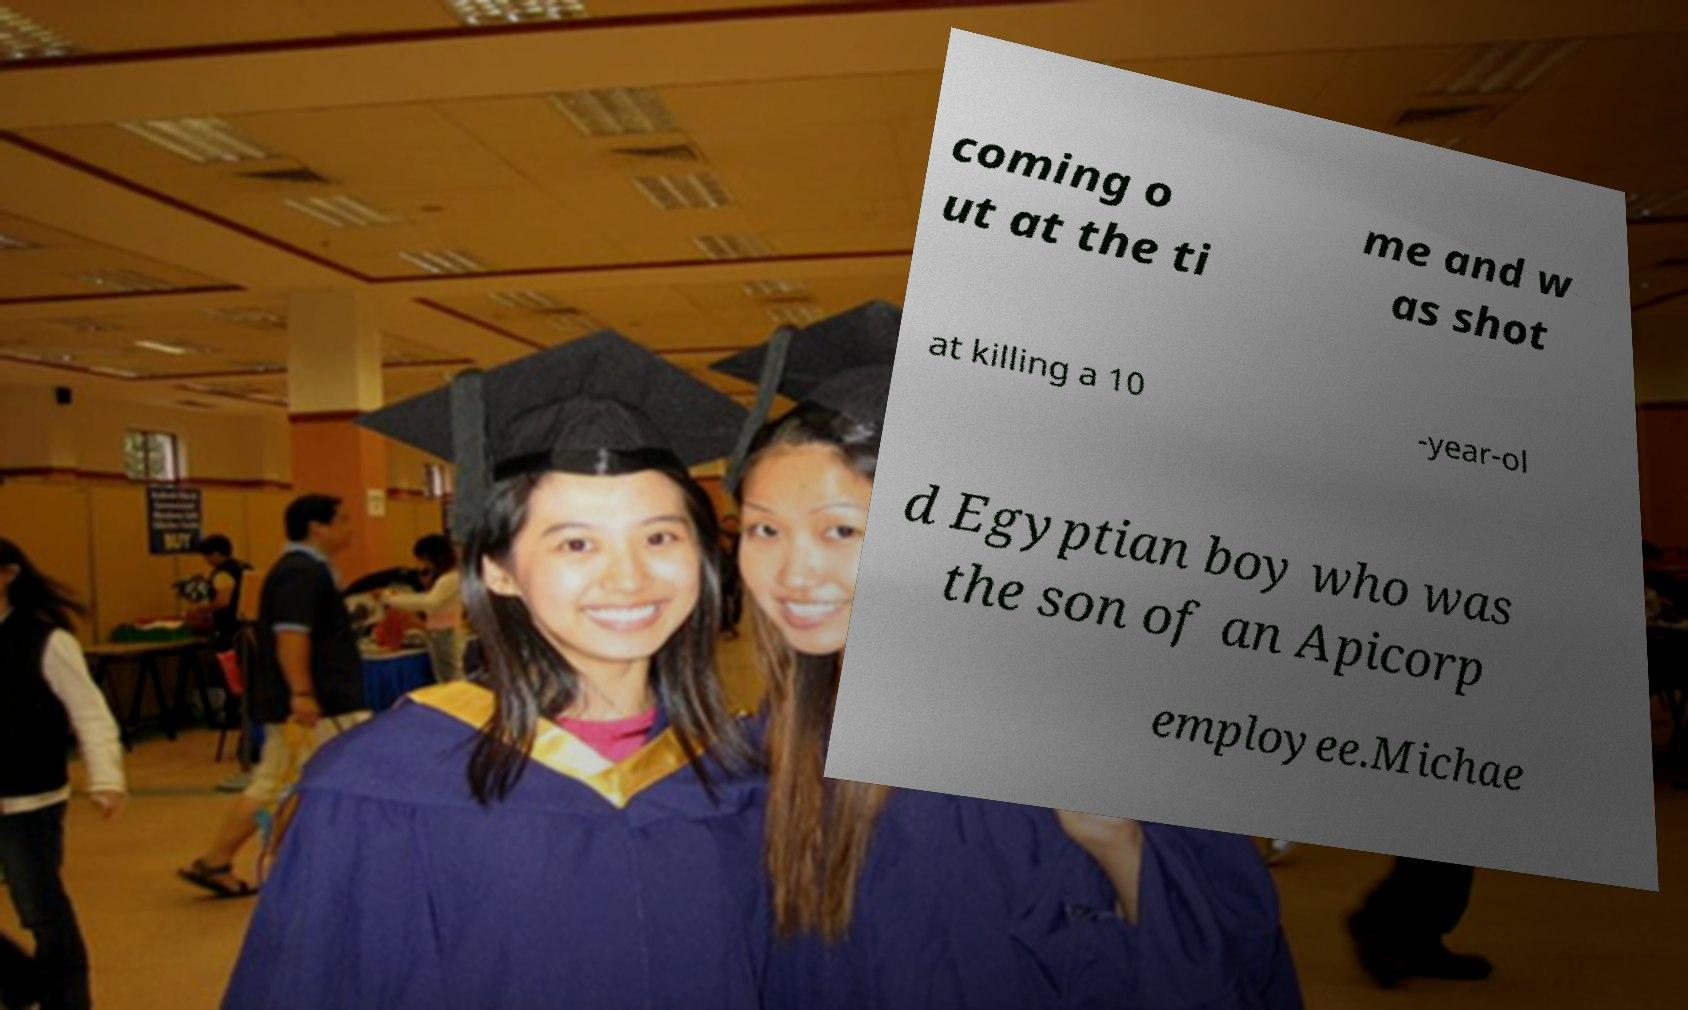Can you read and provide the text displayed in the image?This photo seems to have some interesting text. Can you extract and type it out for me? coming o ut at the ti me and w as shot at killing a 10 -year-ol d Egyptian boy who was the son of an Apicorp employee.Michae 